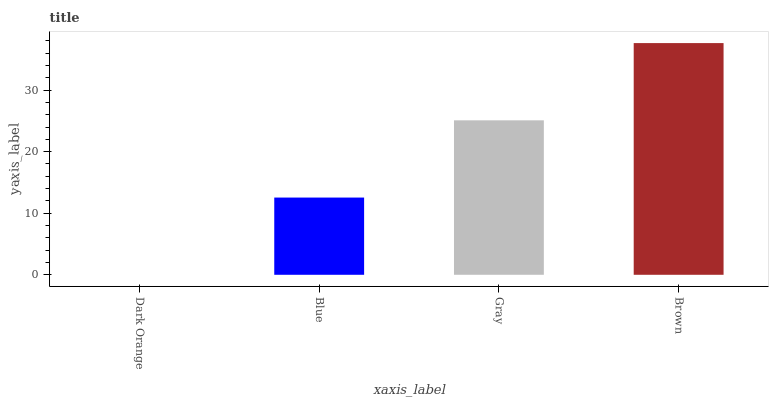Is Dark Orange the minimum?
Answer yes or no. Yes. Is Brown the maximum?
Answer yes or no. Yes. Is Blue the minimum?
Answer yes or no. No. Is Blue the maximum?
Answer yes or no. No. Is Blue greater than Dark Orange?
Answer yes or no. Yes. Is Dark Orange less than Blue?
Answer yes or no. Yes. Is Dark Orange greater than Blue?
Answer yes or no. No. Is Blue less than Dark Orange?
Answer yes or no. No. Is Gray the high median?
Answer yes or no. Yes. Is Blue the low median?
Answer yes or no. Yes. Is Dark Orange the high median?
Answer yes or no. No. Is Dark Orange the low median?
Answer yes or no. No. 